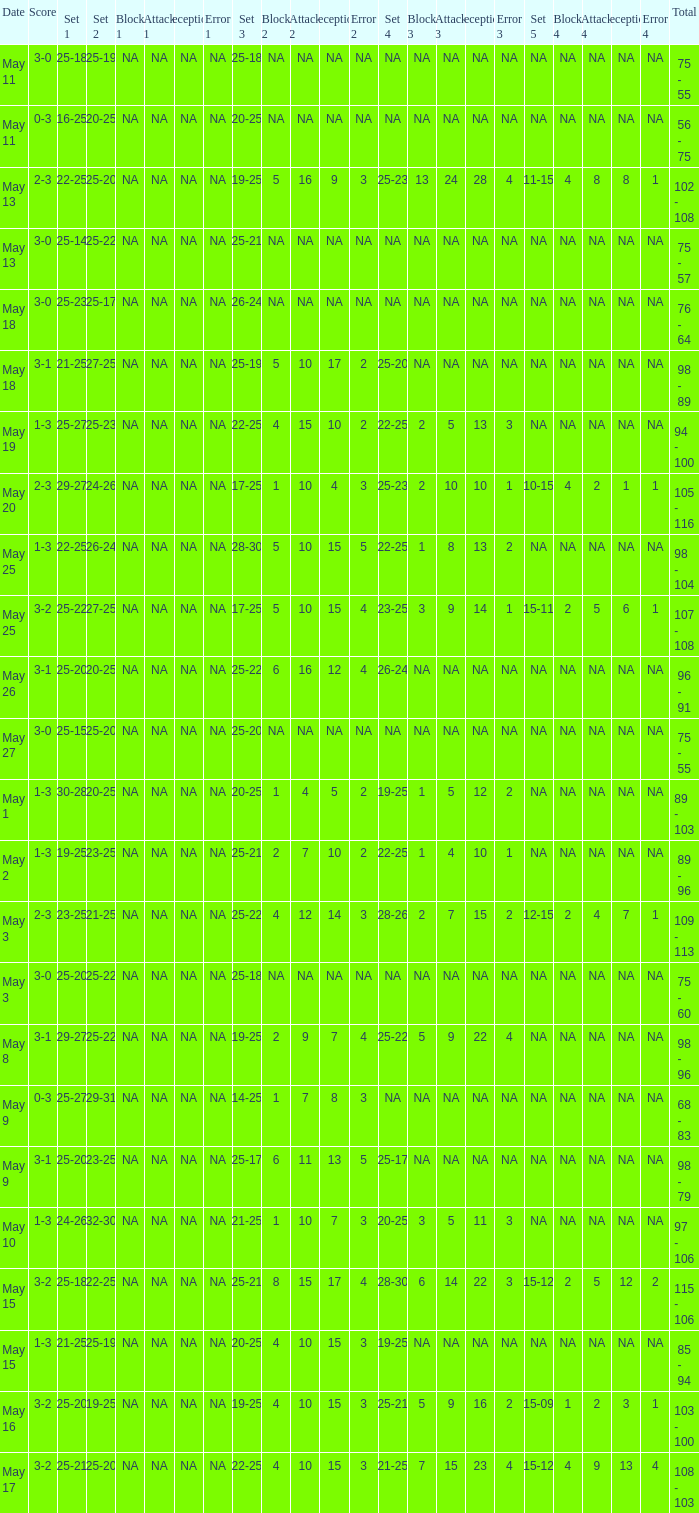What is the set 2 the has 1 set of 21-25, and 4 sets of 25-20? 27-25. 